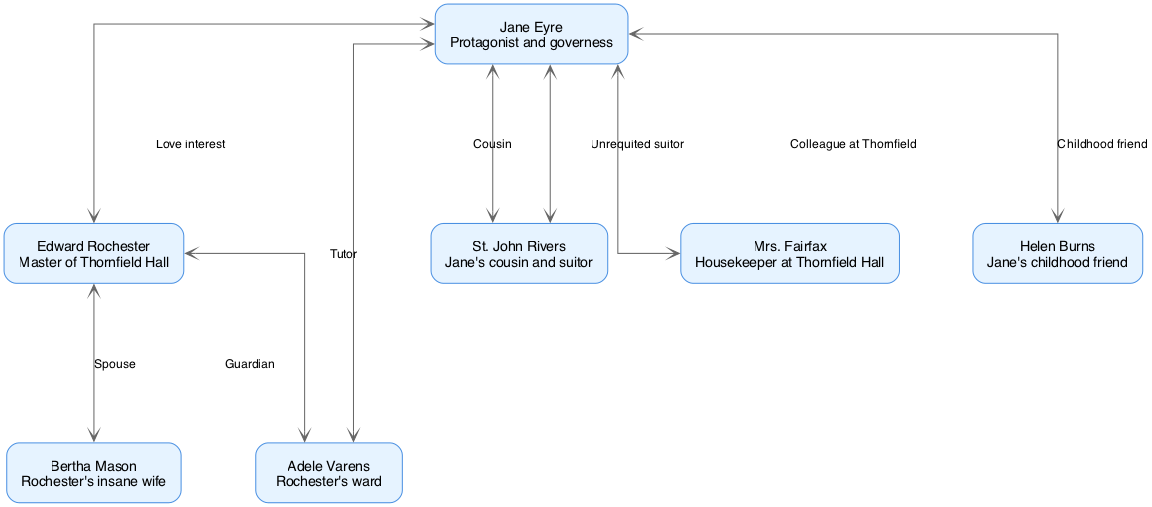What is the name of the protagonist? The diagram identifies "Jane Eyre" as the protagonist, which is stated in the node where Jane Eyre is represented.
Answer: Jane Eyre How many characters are in the diagram? By counting the nodes in the diagram, we see there are 7 characters represented: Jane Eyre, Edward Rochester, Bertha Mason, Adele Varens, St. John Rivers, Mrs. Fairfax, and Helen Burns.
Answer: 7 What is the relationship between Jane Eyre and Edward Rochester? The edge connecting Jane Eyre and Edward Rochester is labeled "Love interest," indicating their relationship.
Answer: Love interest Who is St. John Rivers in relation to Jane Eyre? The diagram shows an edge labeled "Cousin" connecting Jane Eyre and St. John Rivers, highlighting their family relationship.
Answer: Cousin What kind of relationship does Bertha Mason have with Edward Rochester? The edge connecting Bertha Mason and Edward Rochester is labeled "Spouse," indicating that they are married.
Answer: Spouse Which character serves as a tutor for Adele Varens? The diagram specifies that Jane Eyre has a relationship labeled "Tutor" with Adele Varens, indicating her role in Adele's education.
Answer: Tutor How does the relationship between Jane Eyre and St. John Rivers differ from her relationship with Edward Rochester? While Jane is connected to Edward Rochester as a "Love interest," her relationship with St. John Rivers is defined as "Cousin," indicating a familial bond rather than a romantic one.
Answer: Familial bond Who is Jane Eyre's childhood friend according to the diagram? The edge labeled "Childhood friend" connects Jane Eyre with Helen Burns, indicating that Helen is her childhood friend.
Answer: Helen Burns What role does Mrs. Fairfax play in relation to Jane Eyre? The diagram shows a relationship labeled "Colleague at Thornfield" between Jane Eyre and Mrs. Fairfax, signifying a professional relationship.
Answer: Colleague at Thornfield 